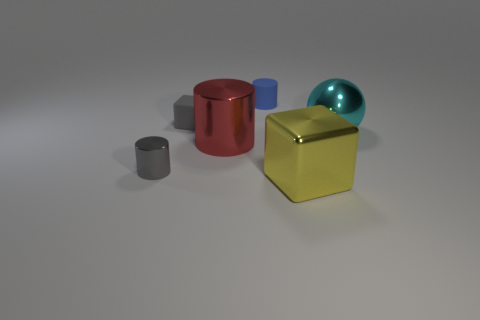What is the color of the other cylinder that is the same size as the matte cylinder?
Your answer should be compact. Gray. What number of objects are either tiny gray objects that are in front of the red cylinder or small red metallic balls?
Keep it short and to the point. 1. How big is the gray thing in front of the tiny gray block?
Offer a very short reply. Small. The object that is made of the same material as the tiny block is what shape?
Your answer should be compact. Cylinder. Is there anything else that has the same color as the small metallic cylinder?
Provide a succinct answer. Yes. There is a large thing that is right of the block in front of the cyan object; what color is it?
Make the answer very short. Cyan. What number of tiny objects are rubber cylinders or cyan metal cubes?
Give a very brief answer. 1. There is another large object that is the same shape as the gray rubber object; what is it made of?
Your response must be concise. Metal. The tiny metallic cylinder is what color?
Make the answer very short. Gray. Do the tiny matte block and the tiny shiny cylinder have the same color?
Give a very brief answer. Yes. 